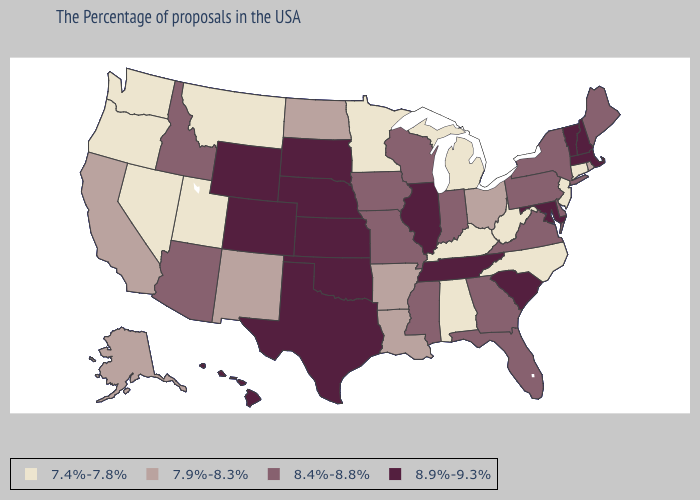Name the states that have a value in the range 8.9%-9.3%?
Short answer required. Massachusetts, New Hampshire, Vermont, Maryland, South Carolina, Tennessee, Illinois, Kansas, Nebraska, Oklahoma, Texas, South Dakota, Wyoming, Colorado, Hawaii. Does Michigan have the lowest value in the MidWest?
Keep it brief. Yes. Among the states that border Nevada , which have the highest value?
Quick response, please. Arizona, Idaho. Does Louisiana have a lower value than Utah?
Give a very brief answer. No. How many symbols are there in the legend?
Quick response, please. 4. Does the first symbol in the legend represent the smallest category?
Keep it brief. Yes. Does the map have missing data?
Be succinct. No. Does New Hampshire have the highest value in the Northeast?
Concise answer only. Yes. How many symbols are there in the legend?
Concise answer only. 4. Which states have the lowest value in the USA?
Give a very brief answer. Connecticut, New Jersey, North Carolina, West Virginia, Michigan, Kentucky, Alabama, Minnesota, Utah, Montana, Nevada, Washington, Oregon. Does Minnesota have the highest value in the MidWest?
Write a very short answer. No. Does Illinois have the lowest value in the MidWest?
Give a very brief answer. No. Name the states that have a value in the range 8.9%-9.3%?
Give a very brief answer. Massachusetts, New Hampshire, Vermont, Maryland, South Carolina, Tennessee, Illinois, Kansas, Nebraska, Oklahoma, Texas, South Dakota, Wyoming, Colorado, Hawaii. Name the states that have a value in the range 7.9%-8.3%?
Concise answer only. Rhode Island, Ohio, Louisiana, Arkansas, North Dakota, New Mexico, California, Alaska. Which states hav the highest value in the West?
Be succinct. Wyoming, Colorado, Hawaii. 